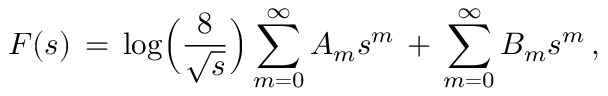<formula> <loc_0><loc_0><loc_500><loc_500>F ( s ) \, = \, \log \left ( \frac { 8 } { \sqrt { s } } \right ) \sum _ { m = 0 } ^ { \infty } A _ { m } s ^ { m } \, + \, \sum _ { m = 0 } ^ { \infty } B _ { m } s ^ { m } \, ,</formula> 